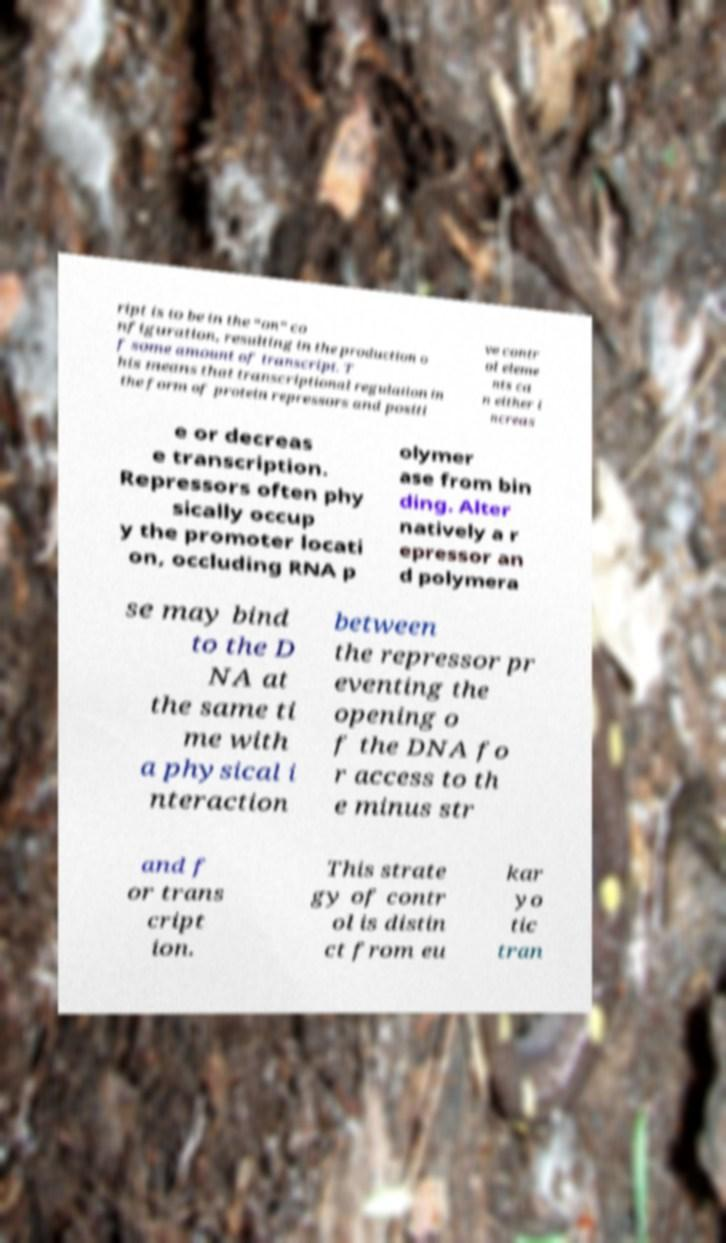Can you accurately transcribe the text from the provided image for me? ript is to be in the “on” co nfiguration, resulting in the production o f some amount of transcript. T his means that transcriptional regulation in the form of protein repressors and positi ve contr ol eleme nts ca n either i ncreas e or decreas e transcription. Repressors often phy sically occup y the promoter locati on, occluding RNA p olymer ase from bin ding. Alter natively a r epressor an d polymera se may bind to the D NA at the same ti me with a physical i nteraction between the repressor pr eventing the opening o f the DNA fo r access to th e minus str and f or trans cript ion. This strate gy of contr ol is distin ct from eu kar yo tic tran 